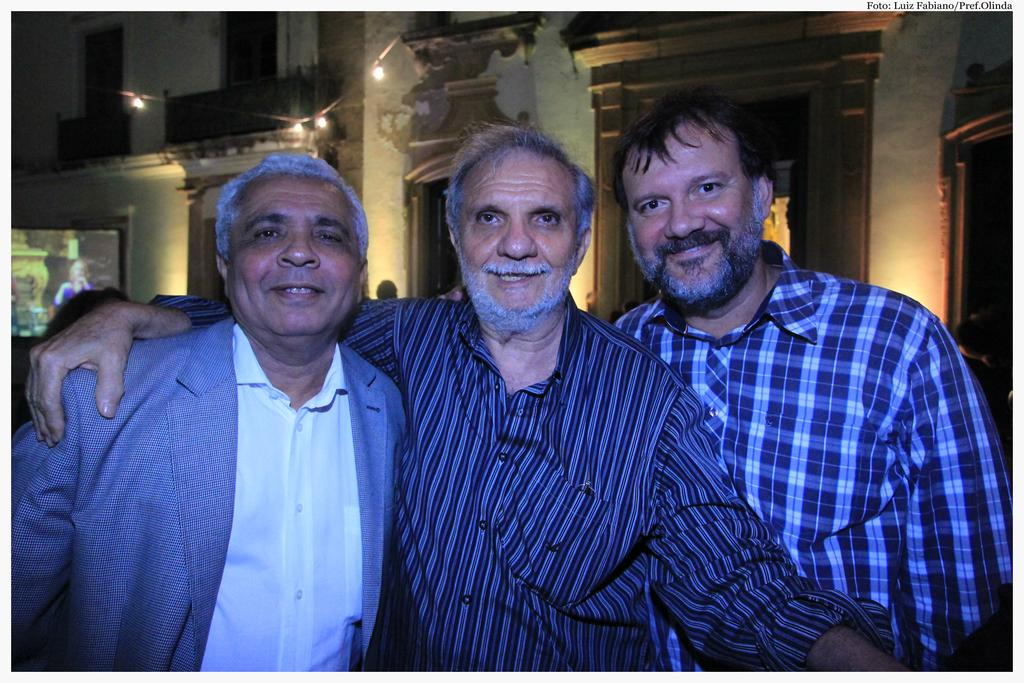How many people are in the image? There are three men standing in the image. What expressions do the men have in the image? All three men are smiling in the image. What can be seen in the background of the image? There is a design on the wall in the background of the image. What can be seen illuminating the scene in the image? There are lights visible in the image. What type of cloth is being used for the voyage in the image? There is no mention of a voyage or cloth in the image; it features three men standing and smiling. 